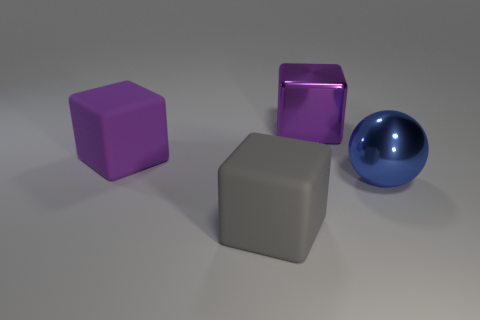Add 1 blue metallic objects. How many objects exist? 5 Subtract all spheres. How many objects are left? 3 Subtract 1 purple cubes. How many objects are left? 3 Subtract all small brown metal spheres. Subtract all large purple objects. How many objects are left? 2 Add 4 shiny objects. How many shiny objects are left? 6 Add 3 purple shiny objects. How many purple shiny objects exist? 4 